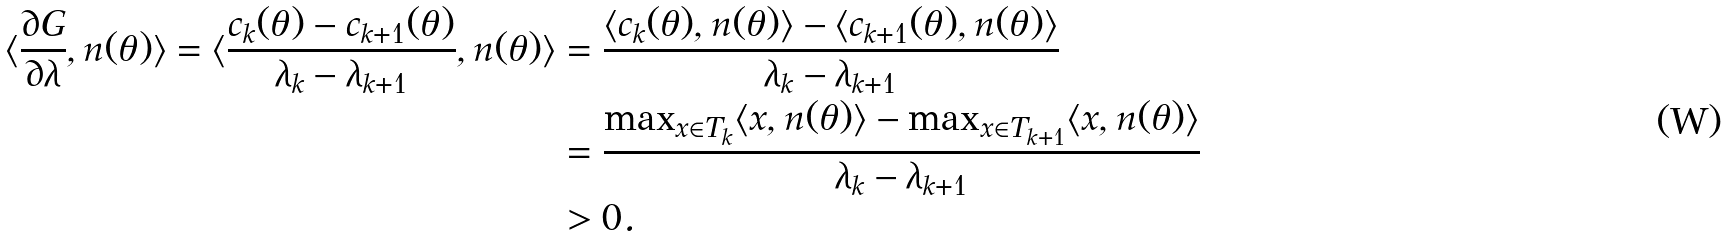Convert formula to latex. <formula><loc_0><loc_0><loc_500><loc_500>\langle \frac { \partial G } { \partial \lambda } , n ( \theta ) \rangle = \langle \frac { c _ { k } ( \theta ) - c _ { k + 1 } ( \theta ) } { \lambda _ { k } - \lambda _ { k + 1 } } , n ( \theta ) \rangle & = \frac { \langle c _ { k } ( \theta ) , n ( \theta ) \rangle - \langle c _ { k + 1 } ( \theta ) , n ( \theta ) \rangle } { \lambda _ { k } - \lambda _ { k + 1 } } \\ & = \frac { \max _ { x \in T _ { k } } \langle x , n ( \theta ) \rangle - \max _ { x \in T _ { k + 1 } } \langle x , n ( \theta ) \rangle } { \lambda _ { k } - \lambda _ { k + 1 } } \\ & > 0 .</formula> 